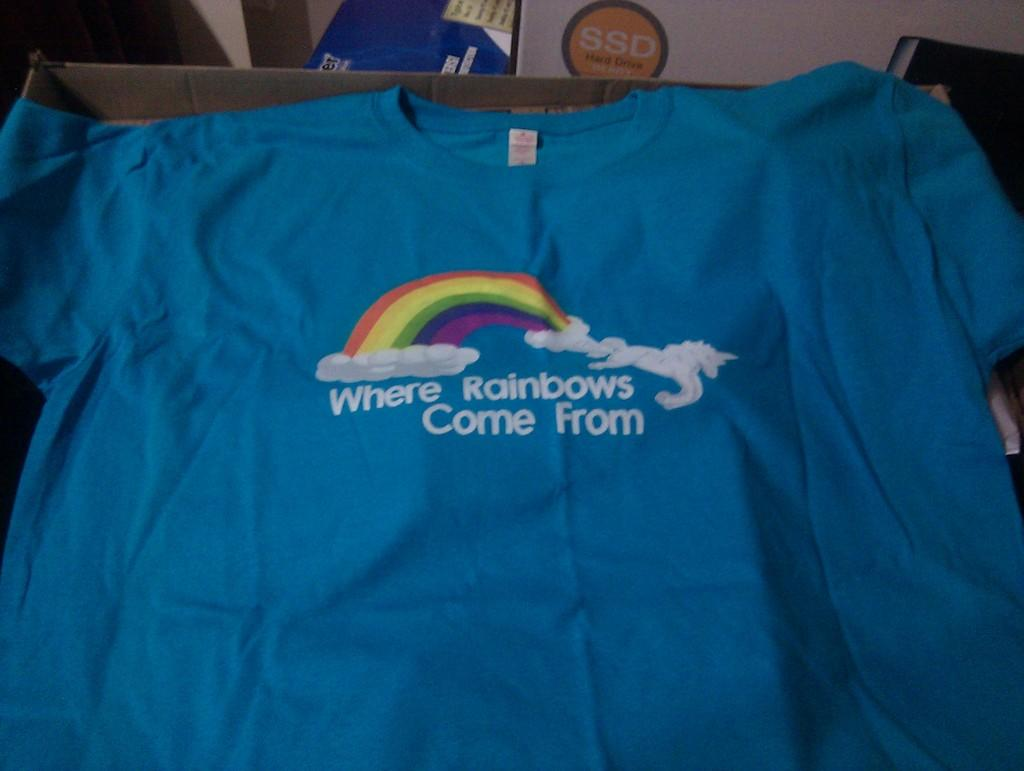<image>
Share a concise interpretation of the image provided. A tshirt with the words Where Rainbows Come From on it. 